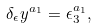Convert formula to latex. <formula><loc_0><loc_0><loc_500><loc_500>\delta _ { \epsilon } y ^ { a _ { 1 } } = \epsilon _ { 3 } ^ { a _ { 1 } } ,</formula> 